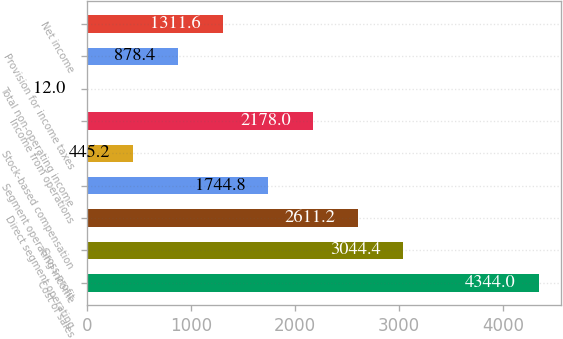<chart> <loc_0><loc_0><loc_500><loc_500><bar_chart><fcel>Cost of sales<fcel>Gross profit<fcel>Direct segment operating<fcel>Segment operating income<fcel>Stock-based compensation<fcel>Income from operations<fcel>Total non-operating income<fcel>Provision for income taxes<fcel>Net income<nl><fcel>4344<fcel>3044.4<fcel>2611.2<fcel>1744.8<fcel>445.2<fcel>2178<fcel>12<fcel>878.4<fcel>1311.6<nl></chart> 